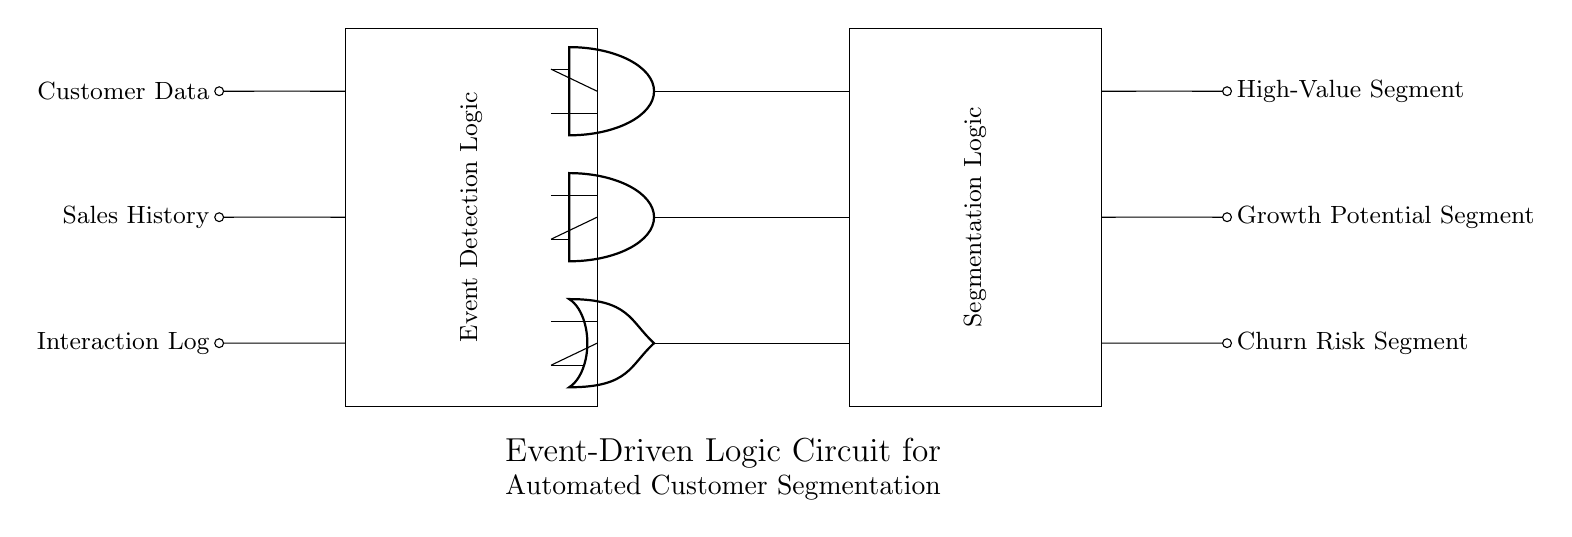What are the primary input signals for this circuit? The primary input signals for this circuit are Customer Data, Sales History, and Interaction Log, as indicated on the left side of the diagram.
Answer: Customer Data, Sales History, Interaction Log What type of logic gates are used in the event detection logic? The logic gates used in the event detection logic are AND and OR gates. The diagram specifically shows two AND gates and one OR gate.
Answer: AND, OR How many output segments are produced by this circuit? The circuit produces three output segments, which are labeled as High-Value Segment, Growth Potential Segment, and Churn Risk Segment.
Answer: Three What kind of logic circuit is illustrated by this diagram? The diagram illustrates an event-driven logic circuit, specifically designed for automated customer segmentation based on the provided input signals.
Answer: Event-driven logic circuit Which logic gate is connected to the High-Value Segment output? The High-Value Segment output is connected to the AND gate labeled as and1. This is indicated by the output connection starting from and1.
Answer: and1 What role does the segmentation logic play in this circuit? The segmentation logic takes the outputs from the event detection logic gates and processes them to classify customers into segments based on their behavior and data, as depicted in the rectangle on the right.
Answer: Classify customers How are the outputs connected to the segmentation logic? The outputs from the AND and OR gates are connected to the segmentation logic using lines that connect to their respective input points in the segmentation logic rectangle. This shows how the circuit processes the results.
Answer: Lines connecting gates to segmentation logic 